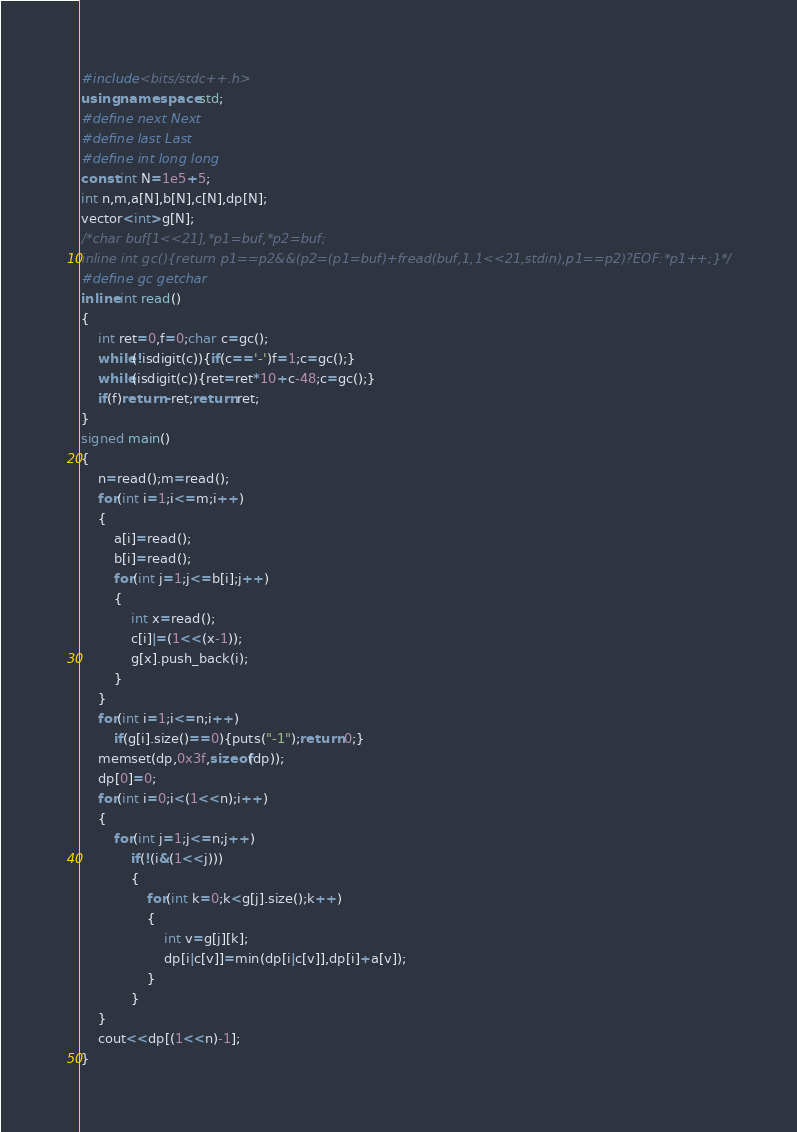Convert code to text. <code><loc_0><loc_0><loc_500><loc_500><_C++_>#include<bits/stdc++.h>
using namespace std;
#define next Next
#define last Last
#define int long long
const int N=1e5+5;
int n,m,a[N],b[N],c[N],dp[N];
vector<int>g[N];
/*char buf[1<<21],*p1=buf,*p2=buf;
inline int gc(){return p1==p2&&(p2=(p1=buf)+fread(buf,1,1<<21,stdin),p1==p2)?EOF:*p1++;}*/
#define gc getchar
inline int read()
{
	int ret=0,f=0;char c=gc();
	while(!isdigit(c)){if(c=='-')f=1;c=gc();}
	while(isdigit(c)){ret=ret*10+c-48;c=gc();}
	if(f)return -ret;return ret;
}
signed main()
{
	n=read();m=read();
	for(int i=1;i<=m;i++)
	{
		a[i]=read();
		b[i]=read();
		for(int j=1;j<=b[i];j++)
		{
			int x=read();
			c[i]|=(1<<(x-1));
			g[x].push_back(i);
		}
	}
	for(int i=1;i<=n;i++)
		if(g[i].size()==0){puts("-1");return 0;}
	memset(dp,0x3f,sizeof(dp));
	dp[0]=0;
	for(int i=0;i<(1<<n);i++)
	{
		for(int j=1;j<=n;j++)
			if(!(i&(1<<j)))
			{
				for(int k=0;k<g[j].size();k++)
				{
					int v=g[j][k];
					dp[i|c[v]]=min(dp[i|c[v]],dp[i]+a[v]);
				}
			}
	}
	cout<<dp[(1<<n)-1];
}</code> 